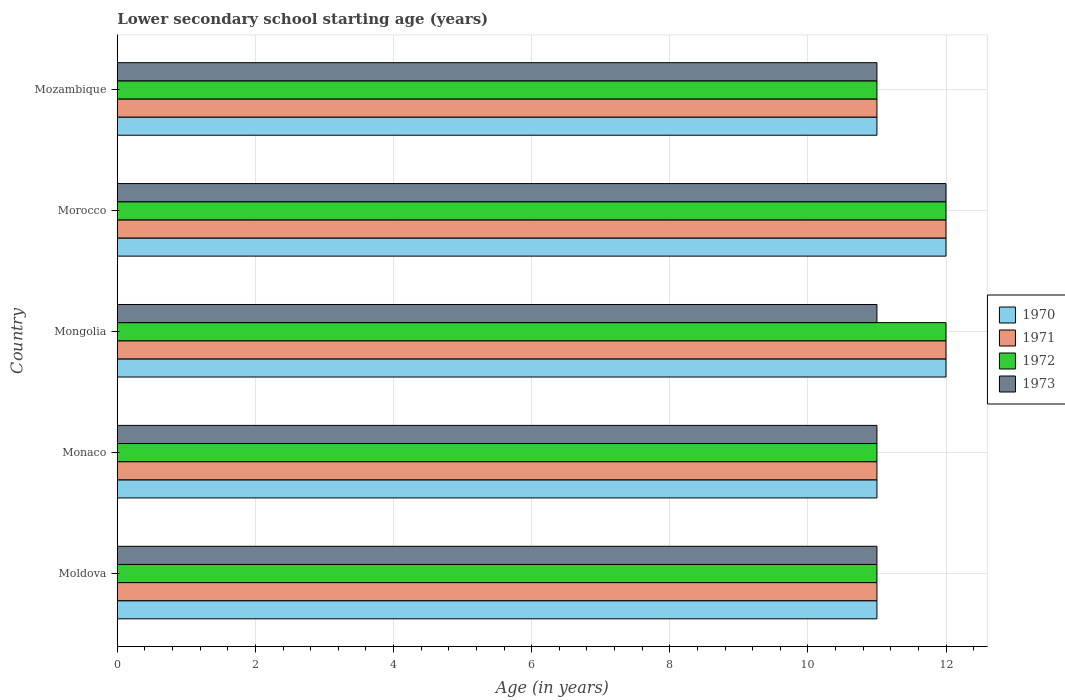Are the number of bars on each tick of the Y-axis equal?
Make the answer very short. Yes. What is the label of the 1st group of bars from the top?
Offer a terse response. Mozambique. In how many cases, is the number of bars for a given country not equal to the number of legend labels?
Make the answer very short. 0. Across all countries, what is the maximum lower secondary school starting age of children in 1970?
Your answer should be compact. 12. Across all countries, what is the minimum lower secondary school starting age of children in 1971?
Offer a very short reply. 11. In which country was the lower secondary school starting age of children in 1973 maximum?
Offer a terse response. Morocco. In which country was the lower secondary school starting age of children in 1972 minimum?
Keep it short and to the point. Moldova. What is the difference between the lower secondary school starting age of children in 1971 in Monaco and that in Mongolia?
Give a very brief answer. -1. What is the difference between the lower secondary school starting age of children in 1973 and lower secondary school starting age of children in 1971 in Morocco?
Offer a very short reply. 0. What is the ratio of the lower secondary school starting age of children in 1970 in Moldova to that in Mozambique?
Keep it short and to the point. 1. What is the difference between the highest and the lowest lower secondary school starting age of children in 1973?
Give a very brief answer. 1. In how many countries, is the lower secondary school starting age of children in 1972 greater than the average lower secondary school starting age of children in 1972 taken over all countries?
Give a very brief answer. 2. What does the 4th bar from the top in Monaco represents?
Give a very brief answer. 1970. How many bars are there?
Provide a short and direct response. 20. How many countries are there in the graph?
Provide a short and direct response. 5. Does the graph contain grids?
Offer a terse response. Yes. How many legend labels are there?
Offer a terse response. 4. What is the title of the graph?
Ensure brevity in your answer.  Lower secondary school starting age (years). Does "1961" appear as one of the legend labels in the graph?
Offer a very short reply. No. What is the label or title of the X-axis?
Your response must be concise. Age (in years). What is the Age (in years) in 1970 in Moldova?
Provide a succinct answer. 11. What is the Age (in years) of 1971 in Moldova?
Keep it short and to the point. 11. What is the Age (in years) of 1972 in Moldova?
Offer a very short reply. 11. What is the Age (in years) in 1973 in Moldova?
Give a very brief answer. 11. What is the Age (in years) in 1972 in Monaco?
Provide a succinct answer. 11. What is the Age (in years) of 1970 in Mongolia?
Your answer should be compact. 12. What is the Age (in years) in 1973 in Mongolia?
Make the answer very short. 11. What is the Age (in years) of 1970 in Morocco?
Your answer should be very brief. 12. What is the Age (in years) of 1971 in Morocco?
Offer a terse response. 12. What is the Age (in years) in 1973 in Morocco?
Provide a succinct answer. 12. What is the Age (in years) in 1972 in Mozambique?
Your answer should be compact. 11. What is the Age (in years) of 1973 in Mozambique?
Provide a succinct answer. 11. Across all countries, what is the maximum Age (in years) of 1970?
Your answer should be compact. 12. Across all countries, what is the maximum Age (in years) in 1973?
Keep it short and to the point. 12. Across all countries, what is the minimum Age (in years) of 1972?
Your response must be concise. 11. What is the difference between the Age (in years) in 1972 in Moldova and that in Monaco?
Provide a short and direct response. 0. What is the difference between the Age (in years) in 1971 in Moldova and that in Mongolia?
Keep it short and to the point. -1. What is the difference between the Age (in years) of 1972 in Moldova and that in Mongolia?
Provide a short and direct response. -1. What is the difference between the Age (in years) of 1971 in Moldova and that in Morocco?
Your answer should be very brief. -1. What is the difference between the Age (in years) of 1972 in Moldova and that in Morocco?
Give a very brief answer. -1. What is the difference between the Age (in years) in 1973 in Moldova and that in Morocco?
Provide a short and direct response. -1. What is the difference between the Age (in years) of 1970 in Moldova and that in Mozambique?
Ensure brevity in your answer.  0. What is the difference between the Age (in years) in 1971 in Moldova and that in Mozambique?
Your response must be concise. 0. What is the difference between the Age (in years) of 1970 in Monaco and that in Mongolia?
Keep it short and to the point. -1. What is the difference between the Age (in years) in 1971 in Monaco and that in Mongolia?
Offer a terse response. -1. What is the difference between the Age (in years) in 1973 in Monaco and that in Mongolia?
Your response must be concise. 0. What is the difference between the Age (in years) in 1970 in Monaco and that in Morocco?
Ensure brevity in your answer.  -1. What is the difference between the Age (in years) in 1971 in Monaco and that in Morocco?
Give a very brief answer. -1. What is the difference between the Age (in years) of 1972 in Monaco and that in Morocco?
Your response must be concise. -1. What is the difference between the Age (in years) of 1970 in Monaco and that in Mozambique?
Offer a very short reply. 0. What is the difference between the Age (in years) of 1971 in Monaco and that in Mozambique?
Make the answer very short. 0. What is the difference between the Age (in years) in 1972 in Monaco and that in Mozambique?
Offer a terse response. 0. What is the difference between the Age (in years) in 1970 in Mongolia and that in Morocco?
Your response must be concise. 0. What is the difference between the Age (in years) in 1971 in Mongolia and that in Morocco?
Make the answer very short. 0. What is the difference between the Age (in years) of 1972 in Mongolia and that in Morocco?
Offer a terse response. 0. What is the difference between the Age (in years) in 1970 in Mongolia and that in Mozambique?
Make the answer very short. 1. What is the difference between the Age (in years) of 1970 in Moldova and the Age (in years) of 1971 in Monaco?
Your answer should be compact. 0. What is the difference between the Age (in years) in 1970 in Moldova and the Age (in years) in 1973 in Monaco?
Your answer should be compact. 0. What is the difference between the Age (in years) in 1971 in Moldova and the Age (in years) in 1972 in Monaco?
Your answer should be very brief. 0. What is the difference between the Age (in years) of 1972 in Moldova and the Age (in years) of 1973 in Monaco?
Keep it short and to the point. 0. What is the difference between the Age (in years) in 1970 in Moldova and the Age (in years) in 1971 in Mongolia?
Offer a very short reply. -1. What is the difference between the Age (in years) of 1970 in Moldova and the Age (in years) of 1973 in Mongolia?
Ensure brevity in your answer.  0. What is the difference between the Age (in years) of 1971 in Moldova and the Age (in years) of 1973 in Mongolia?
Give a very brief answer. 0. What is the difference between the Age (in years) of 1970 in Moldova and the Age (in years) of 1972 in Morocco?
Make the answer very short. -1. What is the difference between the Age (in years) of 1972 in Moldova and the Age (in years) of 1973 in Morocco?
Your answer should be very brief. -1. What is the difference between the Age (in years) in 1970 in Moldova and the Age (in years) in 1973 in Mozambique?
Offer a terse response. 0. What is the difference between the Age (in years) in 1970 in Monaco and the Age (in years) in 1972 in Mongolia?
Your answer should be very brief. -1. What is the difference between the Age (in years) of 1970 in Monaco and the Age (in years) of 1973 in Mongolia?
Your answer should be compact. 0. What is the difference between the Age (in years) of 1971 in Monaco and the Age (in years) of 1972 in Mongolia?
Your answer should be very brief. -1. What is the difference between the Age (in years) of 1971 in Monaco and the Age (in years) of 1973 in Mongolia?
Make the answer very short. 0. What is the difference between the Age (in years) in 1972 in Monaco and the Age (in years) in 1973 in Mongolia?
Your response must be concise. 0. What is the difference between the Age (in years) of 1970 in Monaco and the Age (in years) of 1972 in Morocco?
Your response must be concise. -1. What is the difference between the Age (in years) of 1970 in Monaco and the Age (in years) of 1973 in Morocco?
Give a very brief answer. -1. What is the difference between the Age (in years) of 1970 in Monaco and the Age (in years) of 1971 in Mozambique?
Provide a short and direct response. 0. What is the difference between the Age (in years) in 1972 in Monaco and the Age (in years) in 1973 in Mozambique?
Your answer should be very brief. 0. What is the difference between the Age (in years) in 1970 in Mongolia and the Age (in years) in 1971 in Morocco?
Your answer should be very brief. 0. What is the difference between the Age (in years) of 1970 in Mongolia and the Age (in years) of 1973 in Morocco?
Your answer should be very brief. 0. What is the difference between the Age (in years) of 1971 in Mongolia and the Age (in years) of 1972 in Morocco?
Your answer should be very brief. 0. What is the difference between the Age (in years) of 1971 in Mongolia and the Age (in years) of 1973 in Morocco?
Make the answer very short. 0. What is the difference between the Age (in years) of 1970 in Mongolia and the Age (in years) of 1972 in Mozambique?
Your response must be concise. 1. What is the difference between the Age (in years) of 1970 in Mongolia and the Age (in years) of 1973 in Mozambique?
Provide a succinct answer. 1. What is the difference between the Age (in years) of 1971 in Mongolia and the Age (in years) of 1972 in Mozambique?
Your response must be concise. 1. What is the difference between the Age (in years) of 1971 in Mongolia and the Age (in years) of 1973 in Mozambique?
Give a very brief answer. 1. What is the difference between the Age (in years) in 1972 in Mongolia and the Age (in years) in 1973 in Mozambique?
Make the answer very short. 1. What is the difference between the Age (in years) in 1970 in Morocco and the Age (in years) in 1971 in Mozambique?
Offer a terse response. 1. What is the difference between the Age (in years) of 1970 in Morocco and the Age (in years) of 1972 in Mozambique?
Your answer should be very brief. 1. What is the difference between the Age (in years) of 1970 in Morocco and the Age (in years) of 1973 in Mozambique?
Provide a short and direct response. 1. What is the difference between the Age (in years) in 1971 in Morocco and the Age (in years) in 1972 in Mozambique?
Ensure brevity in your answer.  1. What is the difference between the Age (in years) in 1972 in Morocco and the Age (in years) in 1973 in Mozambique?
Your answer should be very brief. 1. What is the average Age (in years) in 1970 per country?
Offer a terse response. 11.4. What is the average Age (in years) in 1971 per country?
Make the answer very short. 11.4. What is the average Age (in years) of 1972 per country?
Offer a terse response. 11.4. What is the difference between the Age (in years) of 1970 and Age (in years) of 1971 in Moldova?
Your response must be concise. 0. What is the difference between the Age (in years) of 1970 and Age (in years) of 1971 in Monaco?
Provide a succinct answer. 0. What is the difference between the Age (in years) of 1970 and Age (in years) of 1973 in Monaco?
Provide a succinct answer. 0. What is the difference between the Age (in years) in 1971 and Age (in years) in 1973 in Monaco?
Your response must be concise. 0. What is the difference between the Age (in years) in 1972 and Age (in years) in 1973 in Monaco?
Give a very brief answer. 0. What is the difference between the Age (in years) in 1970 and Age (in years) in 1971 in Mongolia?
Offer a terse response. 0. What is the difference between the Age (in years) of 1971 and Age (in years) of 1973 in Mongolia?
Offer a very short reply. 1. What is the difference between the Age (in years) in 1972 and Age (in years) in 1973 in Mongolia?
Your answer should be compact. 1. What is the difference between the Age (in years) in 1970 and Age (in years) in 1972 in Morocco?
Offer a terse response. 0. What is the difference between the Age (in years) of 1970 and Age (in years) of 1973 in Morocco?
Provide a succinct answer. 0. What is the difference between the Age (in years) in 1971 and Age (in years) in 1973 in Morocco?
Offer a terse response. 0. What is the difference between the Age (in years) in 1970 and Age (in years) in 1971 in Mozambique?
Keep it short and to the point. 0. What is the difference between the Age (in years) of 1971 and Age (in years) of 1973 in Mozambique?
Offer a terse response. 0. What is the difference between the Age (in years) in 1972 and Age (in years) in 1973 in Mozambique?
Provide a succinct answer. 0. What is the ratio of the Age (in years) in 1970 in Moldova to that in Monaco?
Give a very brief answer. 1. What is the ratio of the Age (in years) of 1971 in Moldova to that in Monaco?
Provide a short and direct response. 1. What is the ratio of the Age (in years) in 1973 in Moldova to that in Monaco?
Your response must be concise. 1. What is the ratio of the Age (in years) of 1971 in Moldova to that in Mongolia?
Your answer should be compact. 0.92. What is the ratio of the Age (in years) in 1971 in Moldova to that in Morocco?
Your answer should be very brief. 0.92. What is the ratio of the Age (in years) in 1972 in Moldova to that in Morocco?
Your answer should be very brief. 0.92. What is the ratio of the Age (in years) of 1971 in Moldova to that in Mozambique?
Your answer should be very brief. 1. What is the ratio of the Age (in years) in 1972 in Moldova to that in Mozambique?
Give a very brief answer. 1. What is the ratio of the Age (in years) in 1973 in Moldova to that in Mozambique?
Your answer should be very brief. 1. What is the ratio of the Age (in years) in 1970 in Monaco to that in Morocco?
Offer a very short reply. 0.92. What is the ratio of the Age (in years) of 1971 in Monaco to that in Morocco?
Make the answer very short. 0.92. What is the ratio of the Age (in years) of 1973 in Monaco to that in Morocco?
Offer a very short reply. 0.92. What is the ratio of the Age (in years) in 1970 in Monaco to that in Mozambique?
Your response must be concise. 1. What is the ratio of the Age (in years) of 1971 in Monaco to that in Mozambique?
Offer a terse response. 1. What is the ratio of the Age (in years) of 1972 in Monaco to that in Mozambique?
Offer a very short reply. 1. What is the ratio of the Age (in years) in 1973 in Monaco to that in Mozambique?
Your answer should be very brief. 1. What is the ratio of the Age (in years) of 1970 in Mongolia to that in Morocco?
Provide a short and direct response. 1. What is the ratio of the Age (in years) of 1972 in Mongolia to that in Morocco?
Your response must be concise. 1. What is the ratio of the Age (in years) in 1973 in Mongolia to that in Morocco?
Your answer should be very brief. 0.92. What is the ratio of the Age (in years) in 1972 in Mongolia to that in Mozambique?
Make the answer very short. 1.09. What is the ratio of the Age (in years) in 1973 in Mongolia to that in Mozambique?
Give a very brief answer. 1. What is the ratio of the Age (in years) of 1971 in Morocco to that in Mozambique?
Make the answer very short. 1.09. What is the ratio of the Age (in years) of 1972 in Morocco to that in Mozambique?
Ensure brevity in your answer.  1.09. What is the ratio of the Age (in years) of 1973 in Morocco to that in Mozambique?
Make the answer very short. 1.09. What is the difference between the highest and the second highest Age (in years) in 1973?
Keep it short and to the point. 1. What is the difference between the highest and the lowest Age (in years) in 1970?
Offer a terse response. 1. What is the difference between the highest and the lowest Age (in years) in 1971?
Keep it short and to the point. 1. What is the difference between the highest and the lowest Age (in years) of 1973?
Ensure brevity in your answer.  1. 